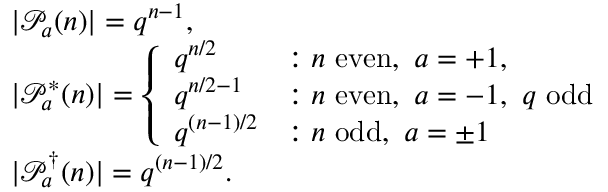Convert formula to latex. <formula><loc_0><loc_0><loc_500><loc_500>\begin{array} { r l } & { | \mathcal { P } _ { a } ( n ) | = q ^ { n - 1 } , } \\ & { | \mathcal { P } _ { a } ^ { * } ( n ) | = \left \{ \begin{array} { l l } { q ^ { n / 2 } } & { \colon n e v e n , a = + 1 , } \\ { q ^ { n / 2 - 1 } } & { \colon n e v e n , a = - 1 , q o d d } \\ { q ^ { ( n - 1 ) / 2 } } & { \colon n o d d , a = \pm 1 } \end{array} } \\ & { | \mathcal { P } _ { a } ^ { \dagger } ( n ) | = q ^ { ( n - 1 ) / 2 } . } \end{array}</formula> 